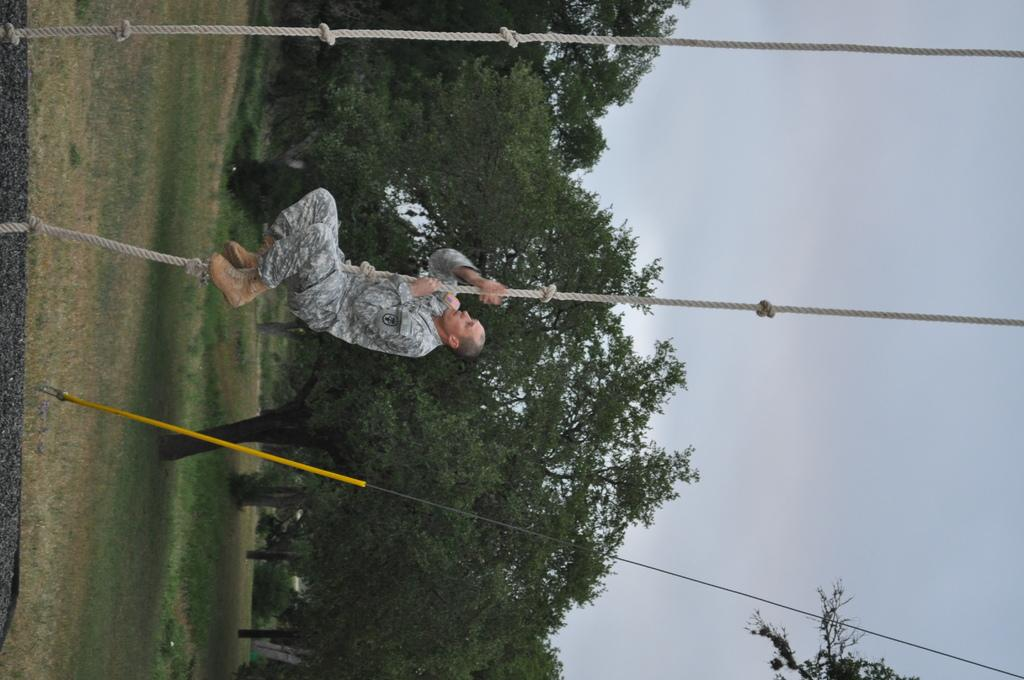What is the main subject of the image? There is a man in the image. What is the man doing in the image? The man is climbing on a rope. What is the man wearing in the image? The man is wearing a uniform. What else can be seen in the image besides the man? There are ropes, trees, and other objects present in the image. What is visible in the background of the image? The sky is visible in the image. What type of gun is the man holding in the image? There is no gun present in the image; the man is climbing on a rope while wearing a uniform. What sign can be seen directing the man's actions in the image? There is no sign present in the image; the man is climbing on a rope without any visible direction. 